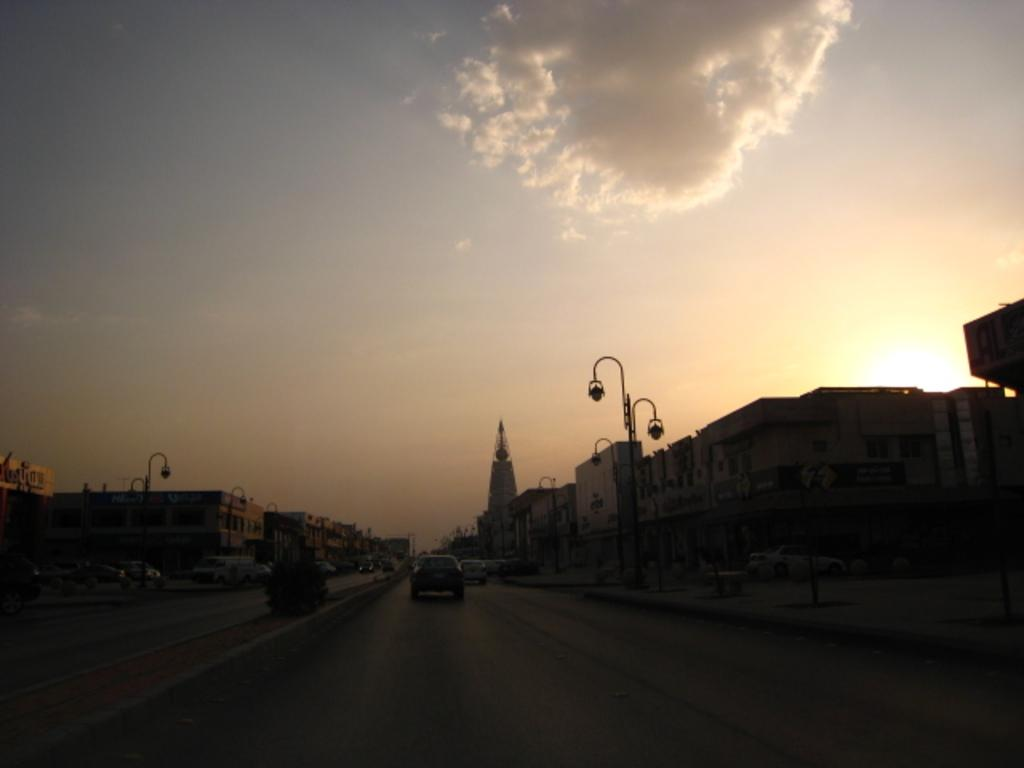What is happening on the road in the image? There are vehicles on the road in the image. What can be seen in the distance behind the vehicles? There are buildings and poles in the background of the image. What is visible in the sky in the image? Clouds are visible in the background of the image. What type of ink is being used to write on the street in the image? There is no ink or writing on the street in the image; it features vehicles on the road. What type of brass objects can be seen in the image? There are no brass objects present in the image. 